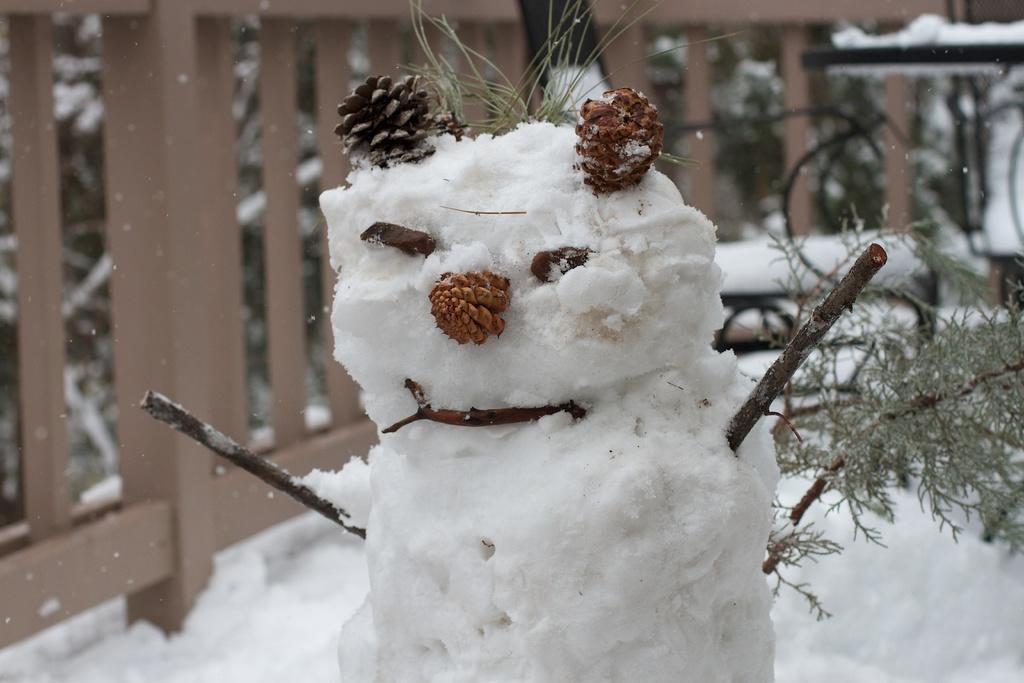Can you describe this image briefly? There is a statue made with snow on the snow surface. In the background, there is a wooden fencing and there are plants on which there is snow. 